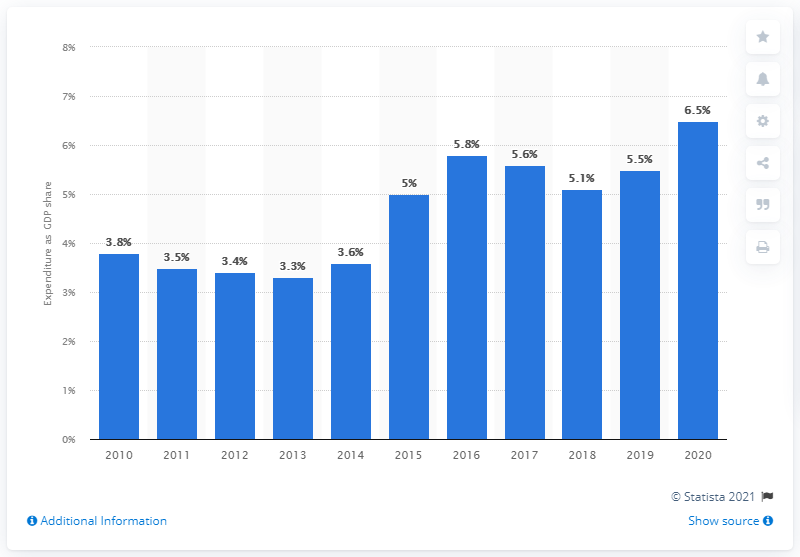Give some essential details in this illustration. In 2020, Kuwait's military expenditure as a percentage of its Gross Domestic Product (GDP) was 6.5%. 